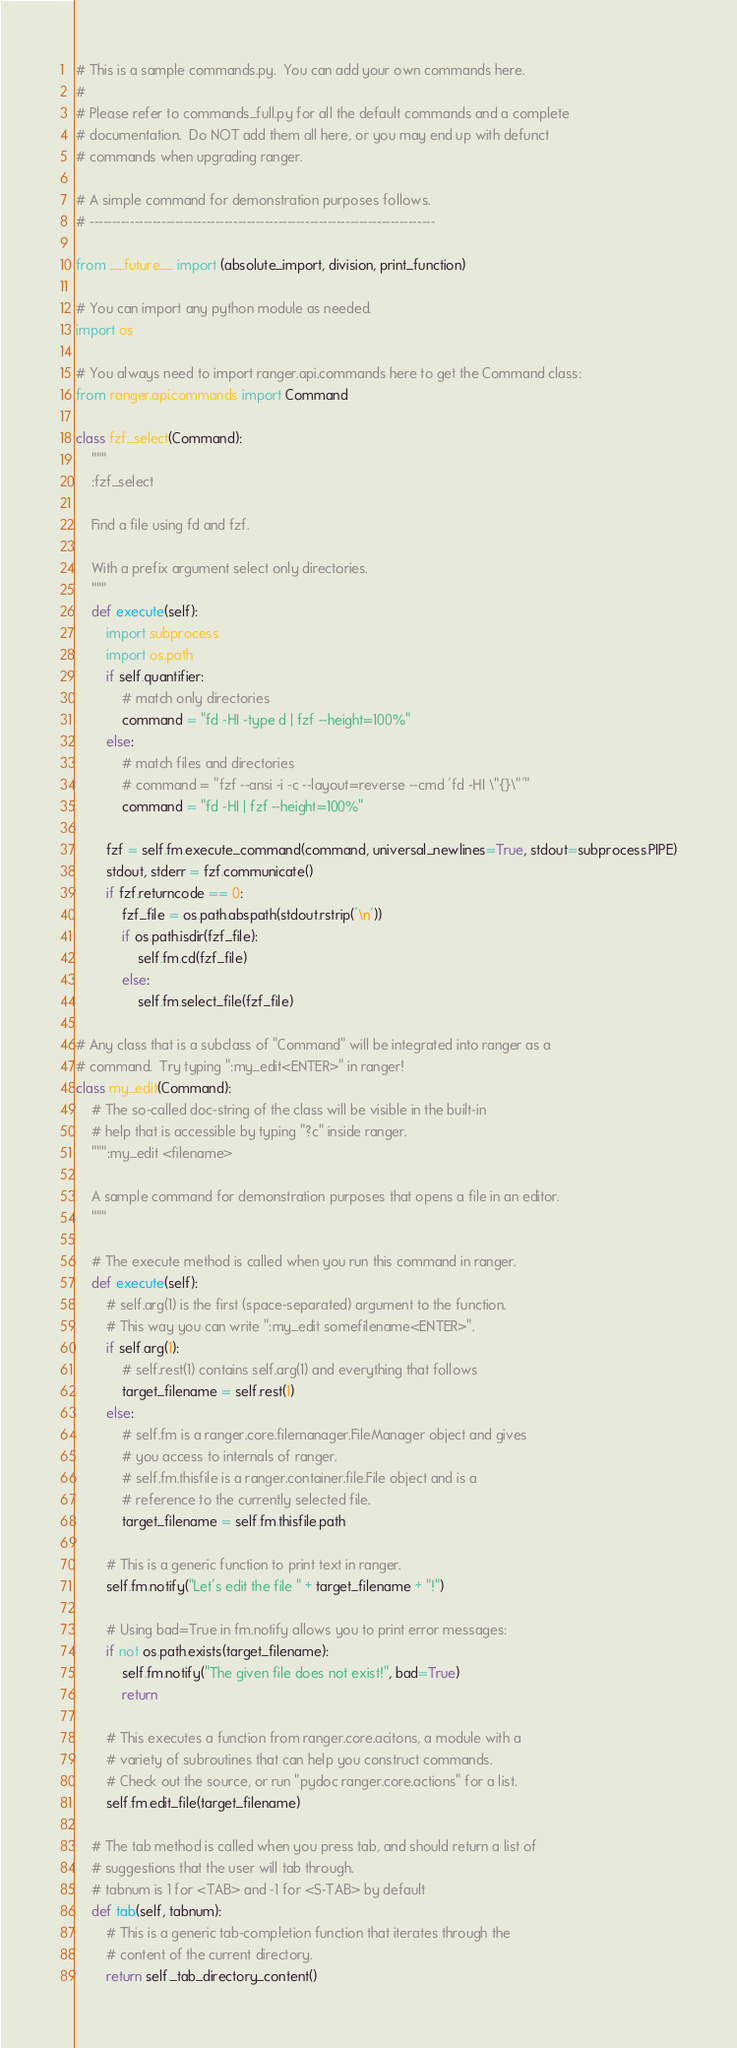Convert code to text. <code><loc_0><loc_0><loc_500><loc_500><_Python_># This is a sample commands.py.  You can add your own commands here.
#
# Please refer to commands_full.py for all the default commands and a complete
# documentation.  Do NOT add them all here, or you may end up with defunct
# commands when upgrading ranger.

# A simple command for demonstration purposes follows.
# -----------------------------------------------------------------------------

from __future__ import (absolute_import, division, print_function)

# You can import any python module as needed.
import os

# You always need to import ranger.api.commands here to get the Command class:
from ranger.api.commands import Command

class fzf_select(Command):
    """
    :fzf_select

    Find a file using fd and fzf.

    With a prefix argument select only directories.
    """
    def execute(self):
        import subprocess
        import os.path
        if self.quantifier:
            # match only directories
            command = "fd -HI -type d | fzf --height=100%"
        else:
            # match files and directories
            # command = "fzf --ansi -i -c --layout=reverse --cmd 'fd -HI \"{}\"'"
            command = "fd -HI | fzf --height=100%"

        fzf = self.fm.execute_command(command, universal_newlines=True, stdout=subprocess.PIPE)
        stdout, stderr = fzf.communicate()
        if fzf.returncode == 0:
            fzf_file = os.path.abspath(stdout.rstrip('\n'))
            if os.path.isdir(fzf_file):
                self.fm.cd(fzf_file)
            else:
                self.fm.select_file(fzf_file)

# Any class that is a subclass of "Command" will be integrated into ranger as a
# command.  Try typing ":my_edit<ENTER>" in ranger!
class my_edit(Command):
    # The so-called doc-string of the class will be visible in the built-in
    # help that is accessible by typing "?c" inside ranger.
    """:my_edit <filename>

    A sample command for demonstration purposes that opens a file in an editor.
    """

    # The execute method is called when you run this command in ranger.
    def execute(self):
        # self.arg(1) is the first (space-separated) argument to the function.
        # This way you can write ":my_edit somefilename<ENTER>".
        if self.arg(1):
            # self.rest(1) contains self.arg(1) and everything that follows
            target_filename = self.rest(1)
        else:
            # self.fm is a ranger.core.filemanager.FileManager object and gives
            # you access to internals of ranger.
            # self.fm.thisfile is a ranger.container.file.File object and is a
            # reference to the currently selected file.
            target_filename = self.fm.thisfile.path

        # This is a generic function to print text in ranger.
        self.fm.notify("Let's edit the file " + target_filename + "!")

        # Using bad=True in fm.notify allows you to print error messages:
        if not os.path.exists(target_filename):
            self.fm.notify("The given file does not exist!", bad=True)
            return

        # This executes a function from ranger.core.acitons, a module with a
        # variety of subroutines that can help you construct commands.
        # Check out the source, or run "pydoc ranger.core.actions" for a list.
        self.fm.edit_file(target_filename)

    # The tab method is called when you press tab, and should return a list of
    # suggestions that the user will tab through.
    # tabnum is 1 for <TAB> and -1 for <S-TAB> by default
    def tab(self, tabnum):
        # This is a generic tab-completion function that iterates through the
        # content of the current directory.
        return self._tab_directory_content()
</code> 